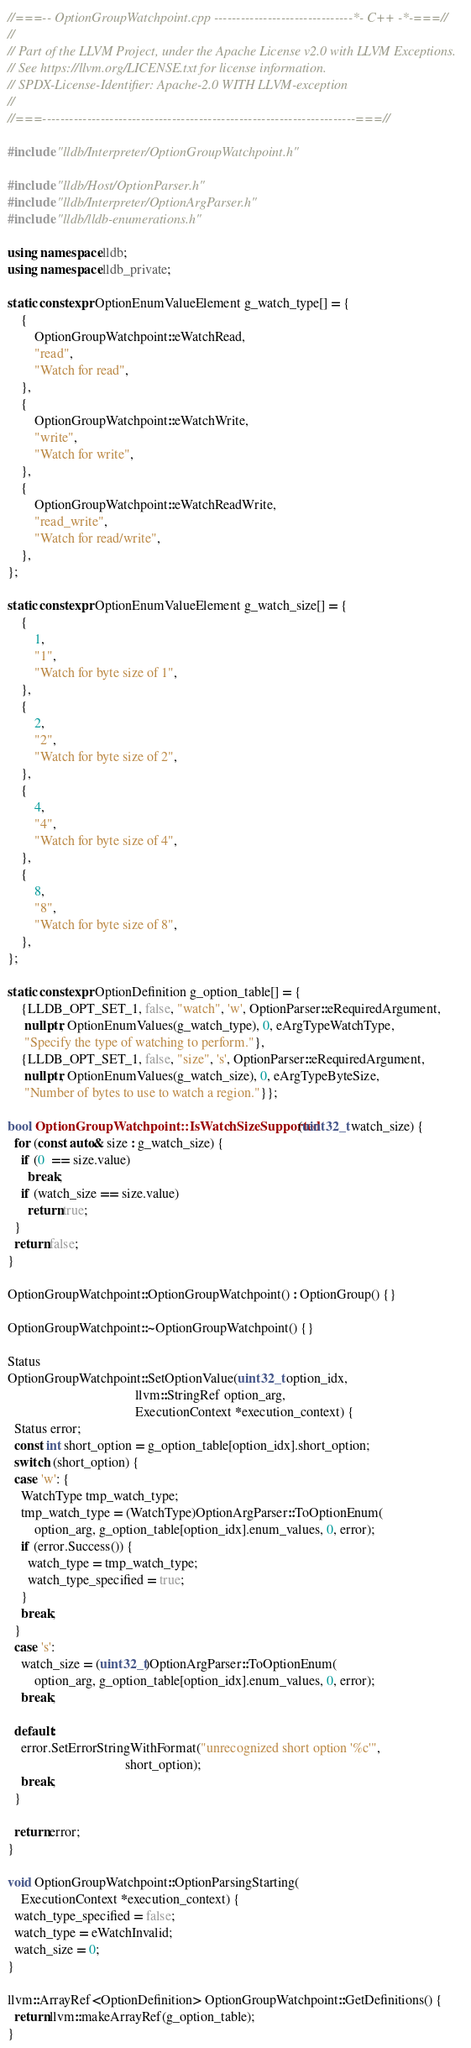Convert code to text. <code><loc_0><loc_0><loc_500><loc_500><_C++_>//===-- OptionGroupWatchpoint.cpp -------------------------------*- C++ -*-===//
//
// Part of the LLVM Project, under the Apache License v2.0 with LLVM Exceptions.
// See https://llvm.org/LICENSE.txt for license information.
// SPDX-License-Identifier: Apache-2.0 WITH LLVM-exception
//
//===----------------------------------------------------------------------===//

#include "lldb/Interpreter/OptionGroupWatchpoint.h"

#include "lldb/Host/OptionParser.h"
#include "lldb/Interpreter/OptionArgParser.h"
#include "lldb/lldb-enumerations.h"

using namespace lldb;
using namespace lldb_private;

static constexpr OptionEnumValueElement g_watch_type[] = {
    {
        OptionGroupWatchpoint::eWatchRead,
        "read",
        "Watch for read",
    },
    {
        OptionGroupWatchpoint::eWatchWrite,
        "write",
        "Watch for write",
    },
    {
        OptionGroupWatchpoint::eWatchReadWrite,
        "read_write",
        "Watch for read/write",
    },
};

static constexpr OptionEnumValueElement g_watch_size[] = {
    {
        1,
        "1",
        "Watch for byte size of 1",
    },
    {
        2,
        "2",
        "Watch for byte size of 2",
    },
    {
        4,
        "4",
        "Watch for byte size of 4",
    },
    {
        8,
        "8",
        "Watch for byte size of 8",
    },
};

static constexpr OptionDefinition g_option_table[] = {
    {LLDB_OPT_SET_1, false, "watch", 'w', OptionParser::eRequiredArgument,
     nullptr, OptionEnumValues(g_watch_type), 0, eArgTypeWatchType,
     "Specify the type of watching to perform."},
    {LLDB_OPT_SET_1, false, "size", 's', OptionParser::eRequiredArgument,
     nullptr, OptionEnumValues(g_watch_size), 0, eArgTypeByteSize,
     "Number of bytes to use to watch a region."}};

bool OptionGroupWatchpoint::IsWatchSizeSupported(uint32_t watch_size) {
  for (const auto& size : g_watch_size) {
    if (0  == size.value)
      break;
    if (watch_size == size.value)
      return true;
  }
  return false;
}

OptionGroupWatchpoint::OptionGroupWatchpoint() : OptionGroup() {}

OptionGroupWatchpoint::~OptionGroupWatchpoint() {}

Status
OptionGroupWatchpoint::SetOptionValue(uint32_t option_idx,
                                      llvm::StringRef option_arg,
                                      ExecutionContext *execution_context) {
  Status error;
  const int short_option = g_option_table[option_idx].short_option;
  switch (short_option) {
  case 'w': {
    WatchType tmp_watch_type;
    tmp_watch_type = (WatchType)OptionArgParser::ToOptionEnum(
        option_arg, g_option_table[option_idx].enum_values, 0, error);
    if (error.Success()) {
      watch_type = tmp_watch_type;
      watch_type_specified = true;
    }
    break;
  }
  case 's':
    watch_size = (uint32_t)OptionArgParser::ToOptionEnum(
        option_arg, g_option_table[option_idx].enum_values, 0, error);
    break;

  default:
    error.SetErrorStringWithFormat("unrecognized short option '%c'",
                                   short_option);
    break;
  }

  return error;
}

void OptionGroupWatchpoint::OptionParsingStarting(
    ExecutionContext *execution_context) {
  watch_type_specified = false;
  watch_type = eWatchInvalid;
  watch_size = 0;
}

llvm::ArrayRef<OptionDefinition> OptionGroupWatchpoint::GetDefinitions() {
  return llvm::makeArrayRef(g_option_table);
}
</code> 